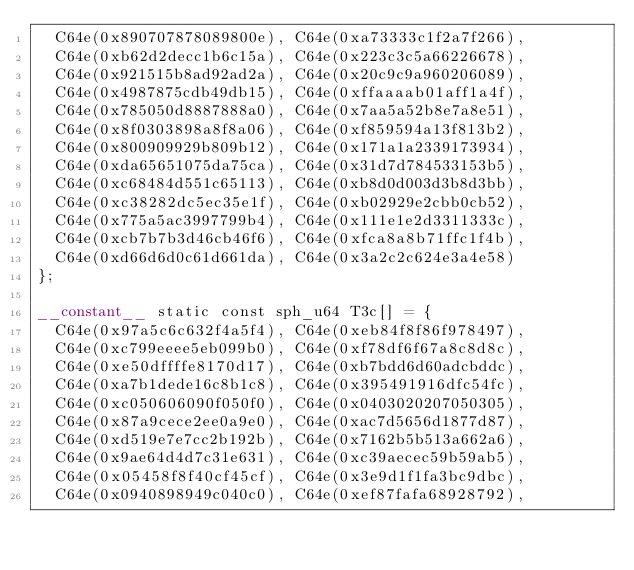<code> <loc_0><loc_0><loc_500><loc_500><_Cuda_>  C64e(0x890707878089800e), C64e(0xa73333c1f2a7f266),
  C64e(0xb62d2decc1b6c15a), C64e(0x223c3c5a66226678),
  C64e(0x921515b8ad92ad2a), C64e(0x20c9c9a960206089),
  C64e(0x4987875cdb49db15), C64e(0xffaaaab01aff1a4f),
  C64e(0x785050d8887888a0), C64e(0x7aa5a52b8e7a8e51),
  C64e(0x8f0303898a8f8a06), C64e(0xf859594a13f813b2),
  C64e(0x800909929b809b12), C64e(0x171a1a2339173934),
  C64e(0xda65651075da75ca), C64e(0x31d7d784533153b5),
  C64e(0xc68484d551c65113), C64e(0xb8d0d003d3b8d3bb),
  C64e(0xc38282dc5ec35e1f), C64e(0xb02929e2cbb0cb52),
  C64e(0x775a5ac3997799b4), C64e(0x111e1e2d3311333c),
  C64e(0xcb7b7b3d46cb46f6), C64e(0xfca8a8b71ffc1f4b),
  C64e(0xd66d6d0c61d661da), C64e(0x3a2c2c624e3a4e58)
};

__constant__ static const sph_u64 T3c[] = {
  C64e(0x97a5c6c632f4a5f4), C64e(0xeb84f8f86f978497),
  C64e(0xc799eeee5eb099b0), C64e(0xf78df6f67a8c8d8c),
  C64e(0xe50dffffe8170d17), C64e(0xb7bdd6d60adcbddc),
  C64e(0xa7b1dede16c8b1c8), C64e(0x395491916dfc54fc),
  C64e(0xc050606090f050f0), C64e(0x0403020207050305),
  C64e(0x87a9cece2ee0a9e0), C64e(0xac7d5656d1877d87),
  C64e(0xd519e7e7cc2b192b), C64e(0x7162b5b513a662a6),
  C64e(0x9ae64d4d7c31e631), C64e(0xc39aecec59b59ab5),
  C64e(0x05458f8f40cf45cf), C64e(0x3e9d1f1fa3bc9dbc),
  C64e(0x0940898949c040c0), C64e(0xef87fafa68928792),</code> 